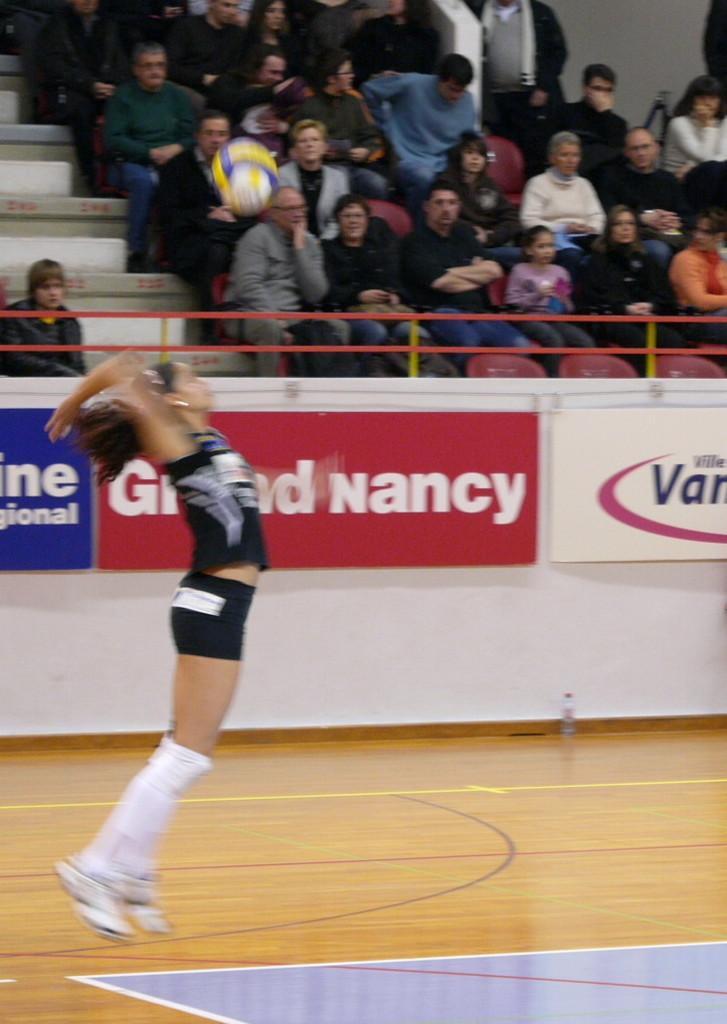Describe this image in one or two sentences. In this picture we can see a girl hitting a ball, she wore shoes, in the background there are some people sitting on stairs, we can see hoardings in the middle. 